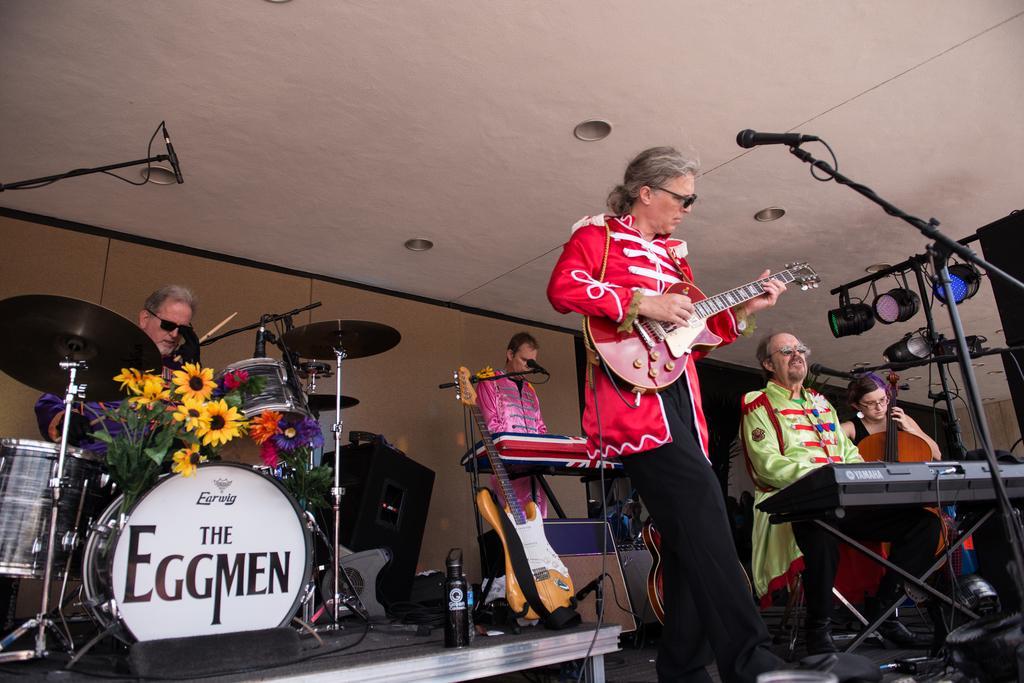Describe this image in one or two sentences. In this picture there are few persons are playing some musical instruments. The person who is standing in the middle of the image is holding guitar in hands and there is a mike stand in front of this person. On the right side of the image two persons are sitting on the chairs, one is playing piano and another one is playing violin. The person who is at the left side is playing the drums. The person who is at the back side is standing and and playing the piano. 